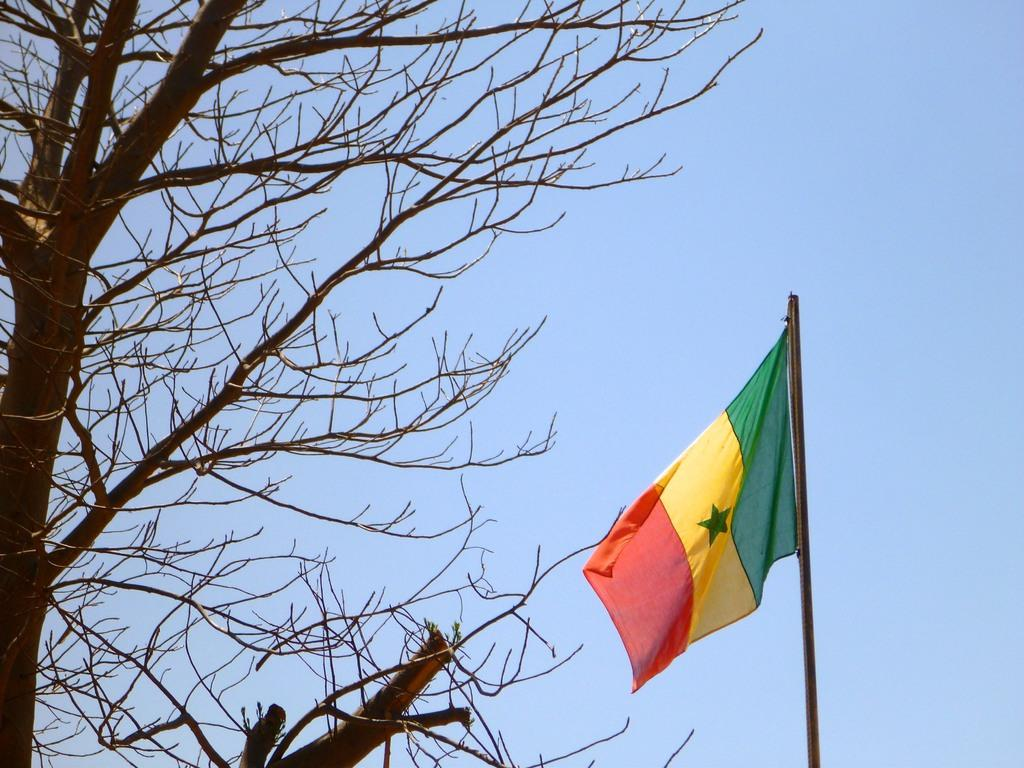What type of plant can be seen in the image? There is a tree in the image. What structure is present near the tree? There is a flag pole in the image. What can be seen in the background of the image? The sky is visible in the background of the image. Where is the seat located in the image? There is no seat present in the image. What type of pain is depicted in the image? There is no depiction of pain in the image. 